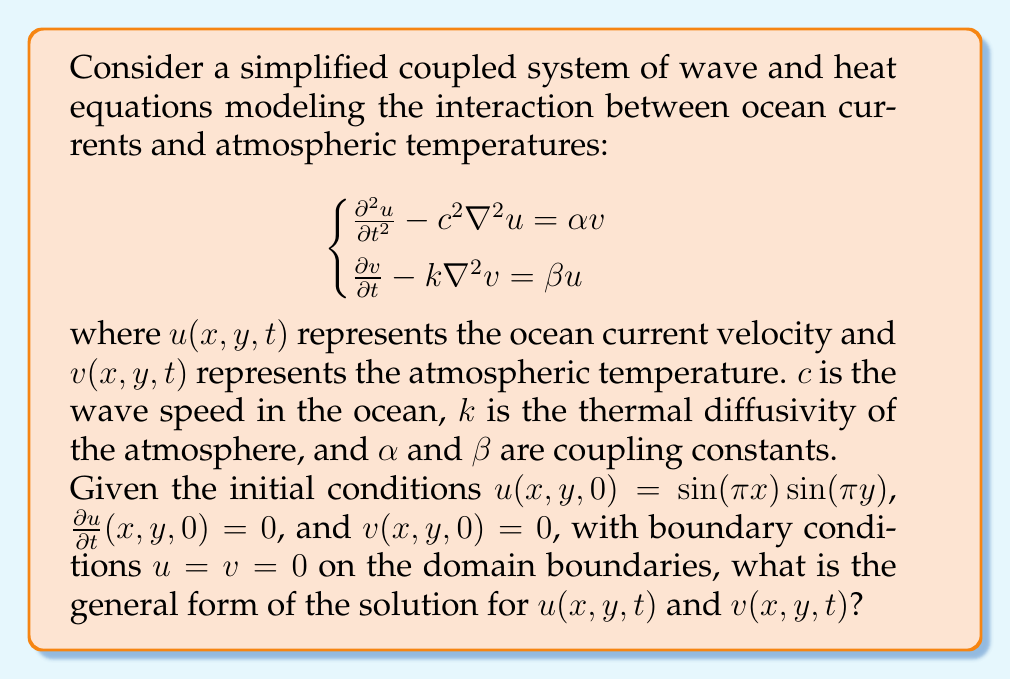Teach me how to tackle this problem. To solve this coupled system, we follow these steps:

1) First, we assume solutions of the form:
   $$u(x,y,t) = X(x)Y(y)T(t)$$
   $$v(x,y,t) = A(x)B(y)S(t)$$

2) Substituting these into the original equations and using separation of variables:

   For $u$: $X''Y + XY'' = -\lambda^2 XY$ where $\lambda^2$ is the separation constant.
   This gives: $X(x) = \sin(n\pi x)$, $Y(y) = \sin(m\pi y)$ for integers $n,m$.

   For $v$: Similar separation gives $A(x) = \sin(n\pi x)$, $B(y) = \sin(m\pi y)$.

3) The time-dependent parts satisfy:
   $$\frac{d^2T}{dt^2} + (c^2\lambda^2)T = \alpha S$$
   $$\frac{dS}{dt} + k\lambda^2S = \beta T$$

   where $\lambda^2 = (n^2 + m^2)\pi^2$.

4) We look for solutions of the form:
   $$T(t) = e^{rt}, S(t) = Ce^{rt}$$

5) Substituting these into the time-dependent equations:
   $$(r^2 + c^2\lambda^2)e^{rt} = \alpha Ce^{rt}$$
   $$(r + k\lambda^2)Ce^{rt} = \beta e^{rt}$$

6) For non-trivial solutions, the determinant must be zero:
   $$\begin{vmatrix}
   r^2 + c^2\lambda^2 & -\alpha \\
   -\beta & r + k\lambda^2
   \end{vmatrix} = 0$$

7) This gives the characteristic equation:
   $$r^3 + k\lambda^2r^2 + c^2\lambda^2r + c^2k\lambda^4 - \alpha\beta = 0$$

8) The general solution will be a linear combination of exponentials with these roots:
   $$u(x,y,t) = \sin(n\pi x)\sin(m\pi y)\sum_{i=1}^3 A_i e^{r_i t}$$
   $$v(x,y,t) = \sin(n\pi x)\sin(m\pi y)\sum_{i=1}^3 B_i e^{r_i t}$$

   where $r_1$, $r_2$, and $r_3$ are the roots of the characteristic equation, and $A_i$ and $B_i$ are constants determined by the initial conditions.

9) The complete solution will be a sum over all possible $n$ and $m$:
   $$u(x,y,t) = \sum_{n,m} \sin(n\pi x)\sin(m\pi y)\sum_{i=1}^3 A_{nmi} e^{r_i t}$$
   $$v(x,y,t) = \sum_{n,m} \sin(n\pi x)\sin(m\pi y)\sum_{i=1}^3 B_{nmi} e^{r_i t}$$
Answer: $$u(x,y,t) = \sum_{n,m} \sin(n\pi x)\sin(m\pi y)\sum_{i=1}^3 A_{nmi} e^{r_i t}$$
$$v(x,y,t) = \sum_{n,m} \sin(n\pi x)\sin(m\pi y)\sum_{i=1}^3 B_{nmi} e^{r_i t}$$ 